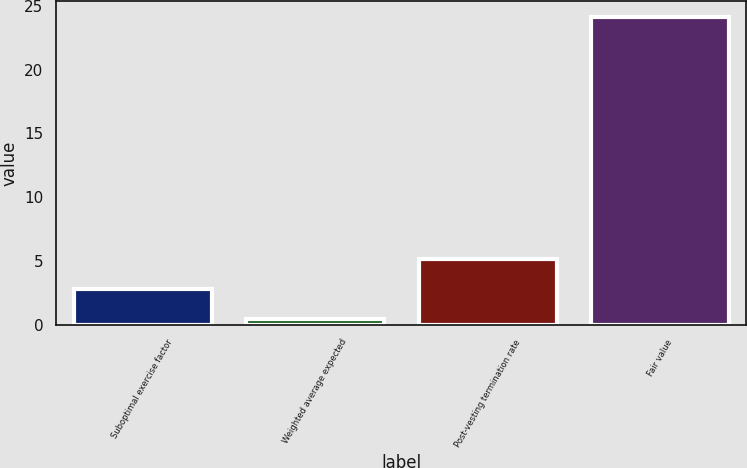Convert chart. <chart><loc_0><loc_0><loc_500><loc_500><bar_chart><fcel>Suboptimal exercise factor<fcel>Weighted average expected<fcel>Post-vesting termination rate<fcel>Fair value<nl><fcel>2.8<fcel>0.43<fcel>5.17<fcel>24.14<nl></chart> 